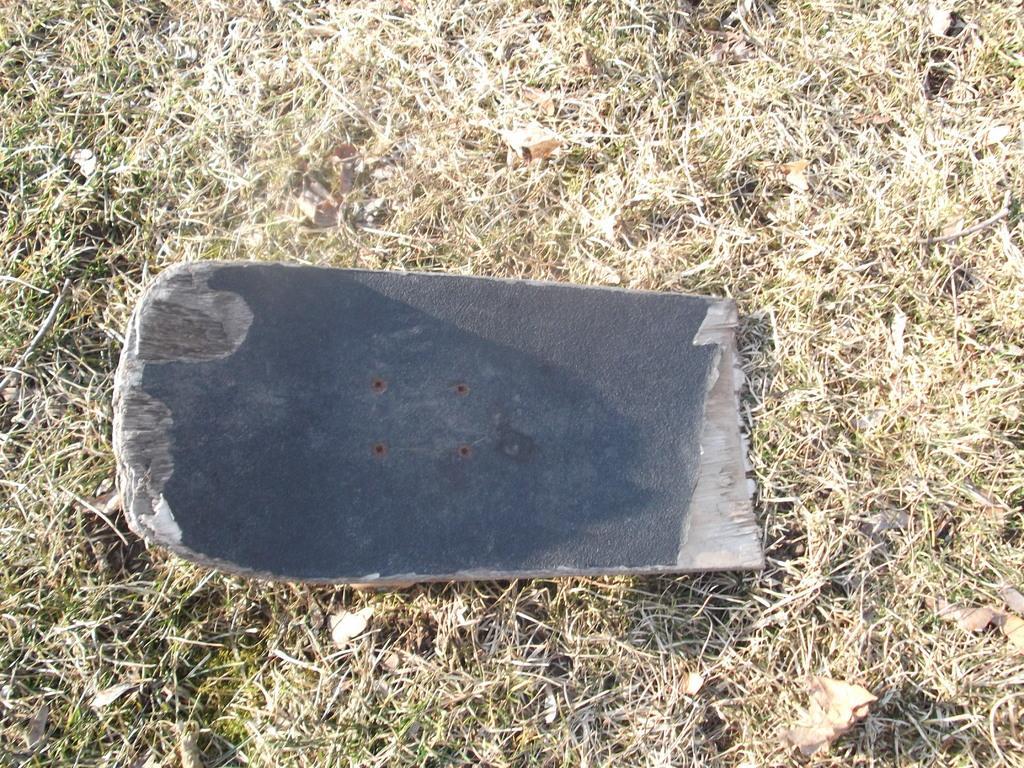In one or two sentences, can you explain what this image depicts? In this image I can see an object which is in gray color. Background I can see dried grass. 